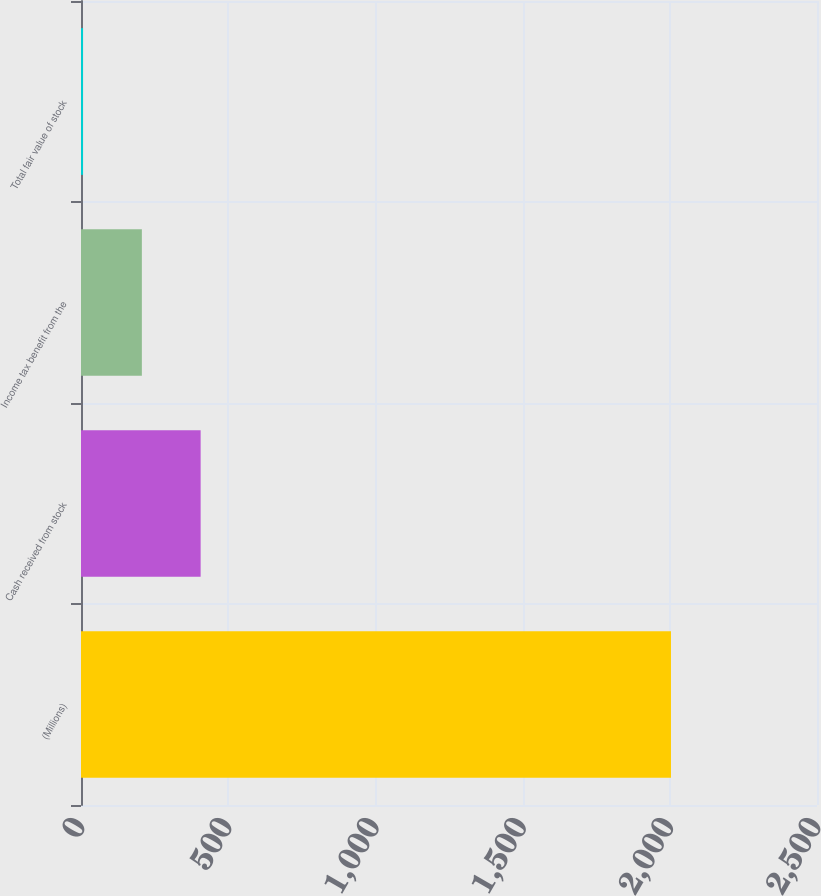<chart> <loc_0><loc_0><loc_500><loc_500><bar_chart><fcel>(Millions)<fcel>Cash received from stock<fcel>Income tax benefit from the<fcel>Total fair value of stock<nl><fcel>2004<fcel>406.4<fcel>206.7<fcel>7<nl></chart> 